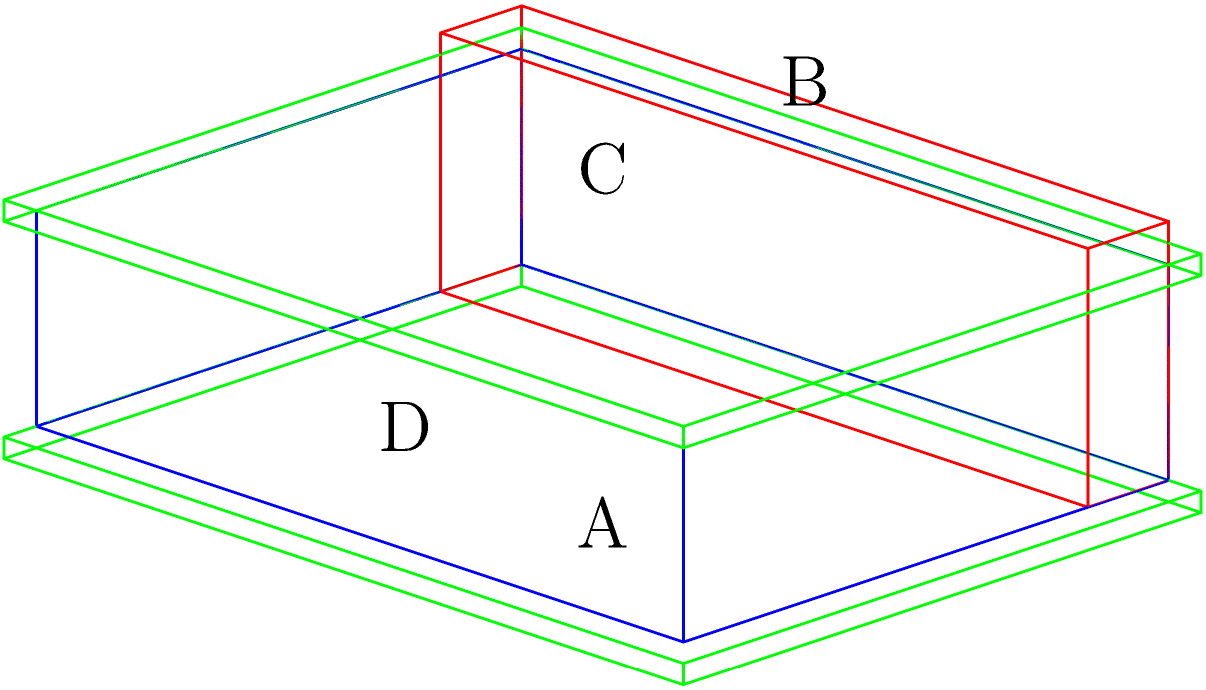Which letter in the diagram represents the spine of a medieval book binding? To identify the correct cross-section of a medieval book binding, let's analyze each part of the diagram:

1. The blue rectangular prism represents the book block, which contains the pages of the manuscript.

2. The green flat rectangles on the top and bottom of the book block represent the front and back covers, respectively. These are typically made of wood or leather in medieval books.

3. The red narrow rectangular prism along the left edge of the book block represents the spine. This is where the pages are sewn together and attached to the covers.

4. The labels in the diagram correspond to different parts of the book:
   A: Front cover
   B: Spine
   C: Back cover
   D: Edge of the pages (fore-edge)

The spine (B) is a crucial element in medieval book binding. It holds the pages together and connects them to the covers. It's often reinforced with additional material to withstand repeated opening and closing of the book.
Answer: B 